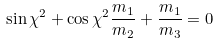Convert formula to latex. <formula><loc_0><loc_0><loc_500><loc_500>\sin \chi ^ { 2 } + \cos \chi ^ { 2 } \frac { m _ { 1 } } { m _ { 2 } } + \frac { m _ { 1 } } { m _ { 3 } } = 0</formula> 